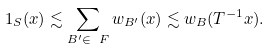Convert formula to latex. <formula><loc_0><loc_0><loc_500><loc_500>1 _ { S } ( x ) \lesssim \sum _ { B ^ { \prime } \in \ F } w _ { B ^ { \prime } } ( x ) \lesssim w _ { B } ( T ^ { - 1 } x ) .</formula> 